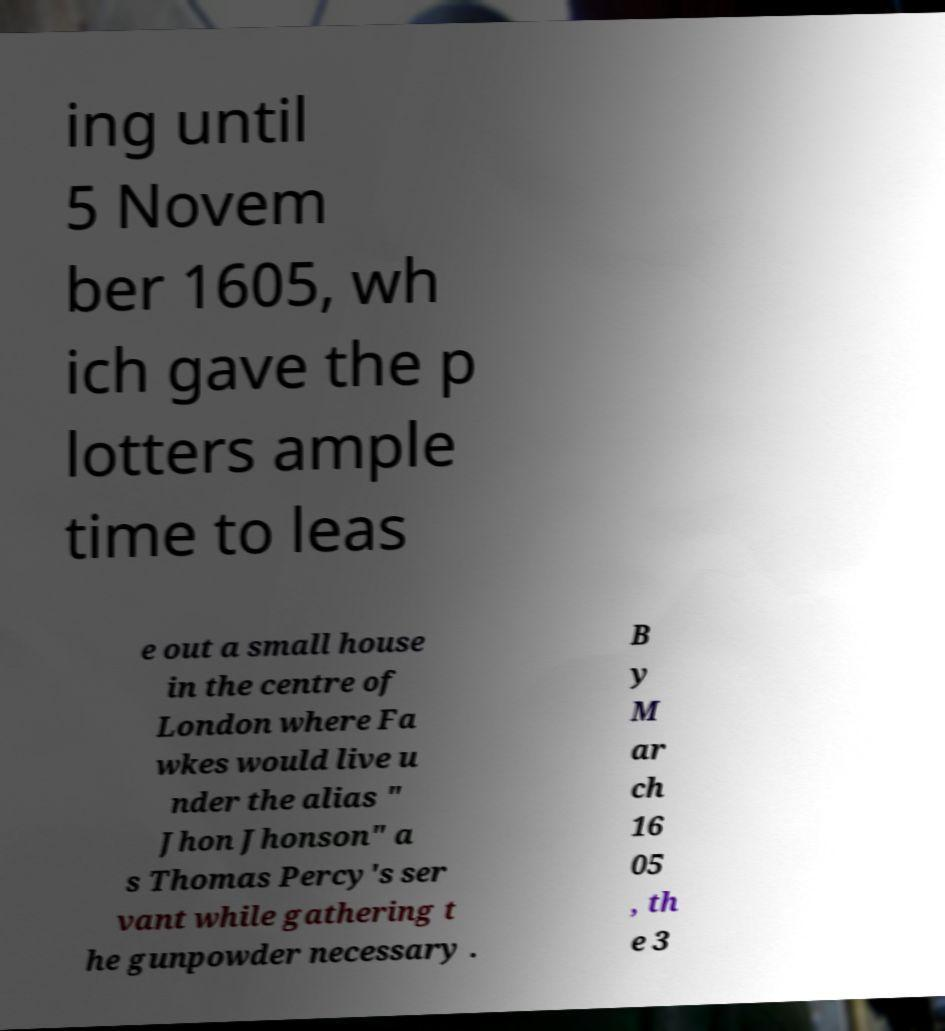What messages or text are displayed in this image? I need them in a readable, typed format. ing until 5 Novem ber 1605, wh ich gave the p lotters ample time to leas e out a small house in the centre of London where Fa wkes would live u nder the alias " Jhon Jhonson" a s Thomas Percy's ser vant while gathering t he gunpowder necessary . B y M ar ch 16 05 , th e 3 